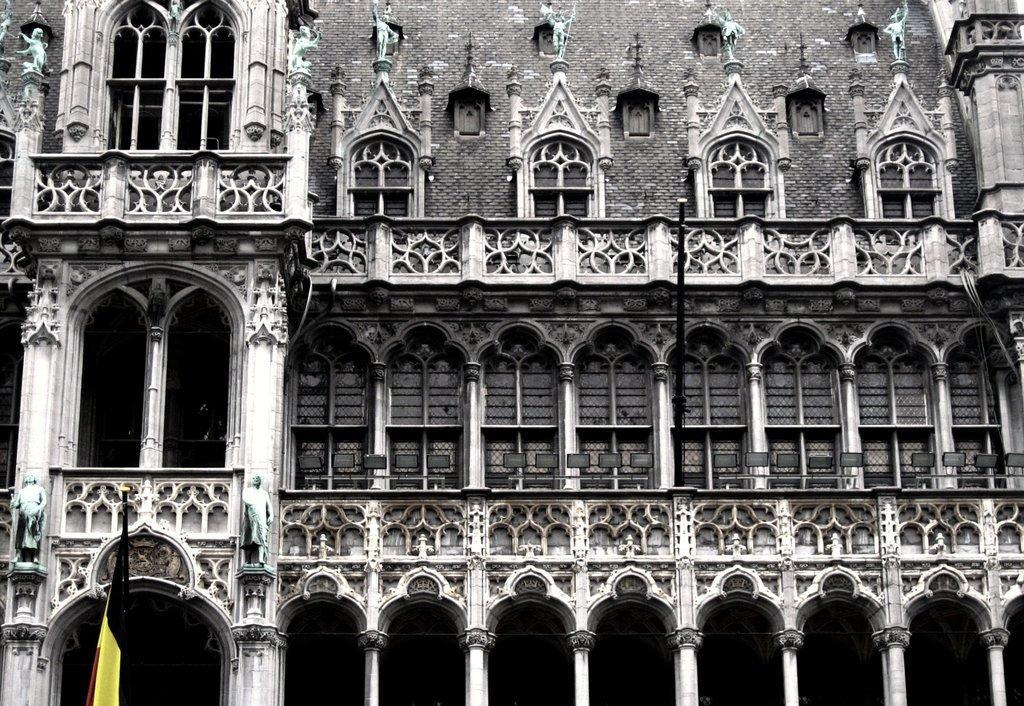Please provide a concise description of this image. In this image, on the left side, we can see a flag. In the background, there are some sculptures, buildings, windows, pillars. 